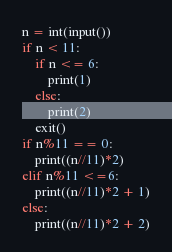<code> <loc_0><loc_0><loc_500><loc_500><_Python_>n = int(input())
if n < 11:
    if n <= 6:
        print(1)
    else:
        print(2)
    exit()
if n%11 == 0:
    print((n//11)*2)
elif n%11 <=6:
    print((n//11)*2 + 1)
else:
    print((n//11)*2 + 2)</code> 